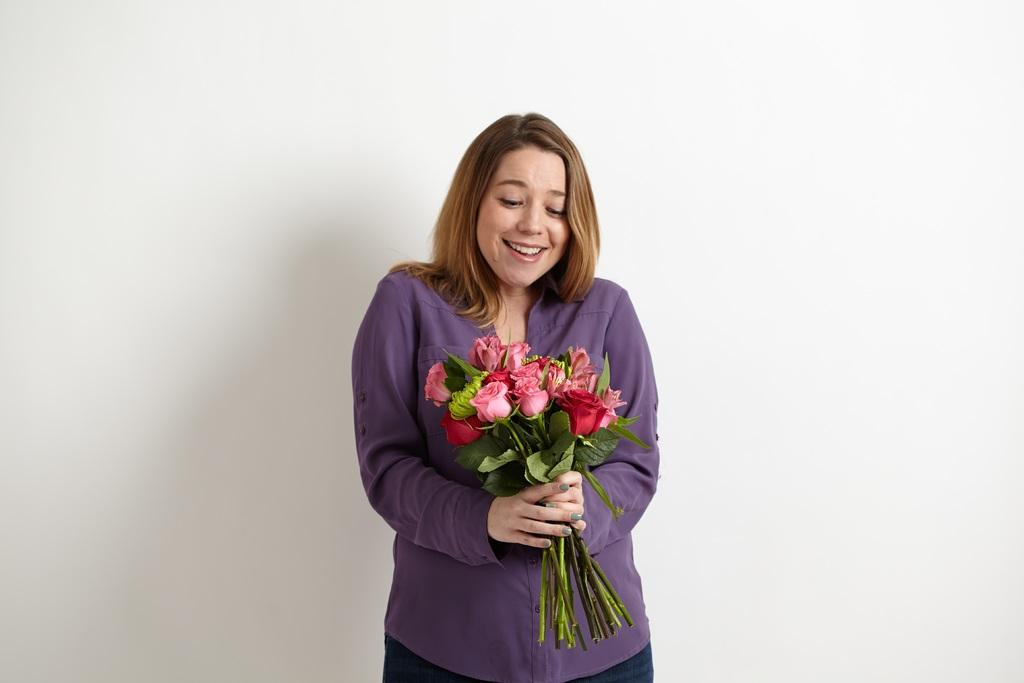Who is the main subject in the picture? There is a woman in the picture. What is the woman doing in the image? The woman is standing and holding a bunch of flowers. What is the background of the image? There is a white backdrop in the image. What type of eggnog can be seen in the woman's hand in the image? There is no eggnog present in the image; the woman is holding a bunch of flowers. 